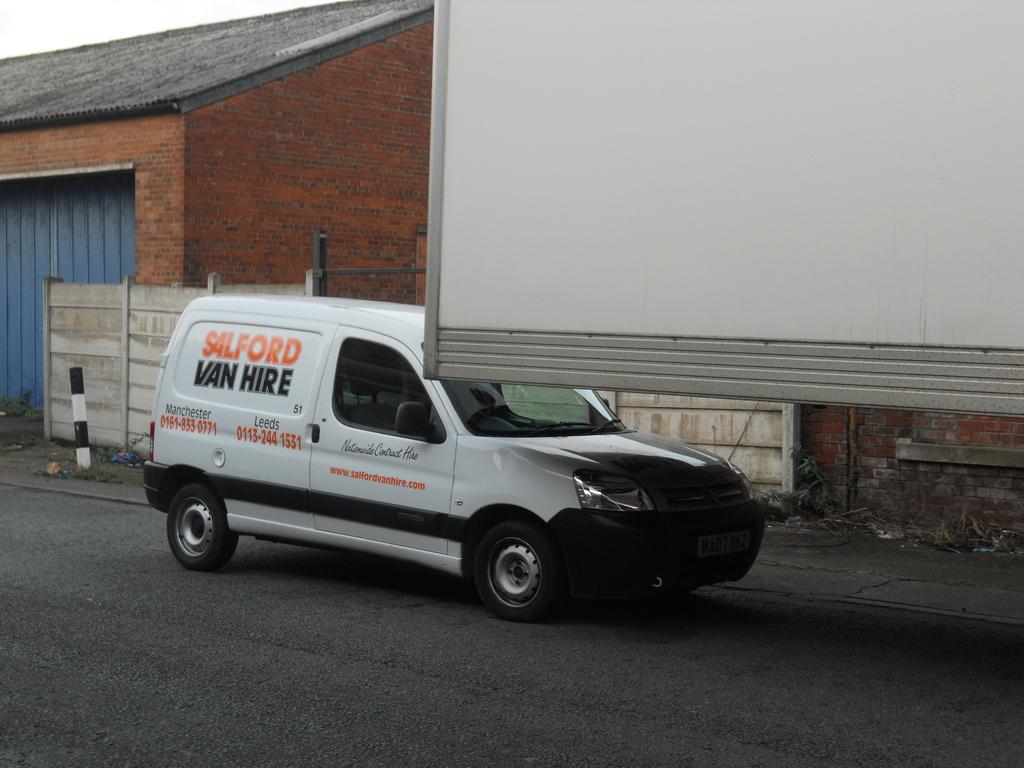<image>
Describe the image concisely. A van from Salford van hire is behind a big white corner of a semi. 